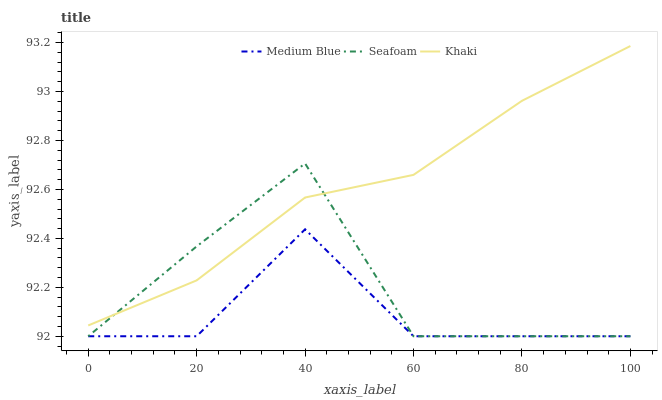Does Medium Blue have the minimum area under the curve?
Answer yes or no. Yes. Does Khaki have the maximum area under the curve?
Answer yes or no. Yes. Does Seafoam have the minimum area under the curve?
Answer yes or no. No. Does Seafoam have the maximum area under the curve?
Answer yes or no. No. Is Khaki the smoothest?
Answer yes or no. Yes. Is Seafoam the roughest?
Answer yes or no. Yes. Is Medium Blue the smoothest?
Answer yes or no. No. Is Medium Blue the roughest?
Answer yes or no. No. Does Khaki have the highest value?
Answer yes or no. Yes. Does Seafoam have the highest value?
Answer yes or no. No. Is Medium Blue less than Khaki?
Answer yes or no. Yes. Is Khaki greater than Medium Blue?
Answer yes or no. Yes. Does Seafoam intersect Medium Blue?
Answer yes or no. Yes. Is Seafoam less than Medium Blue?
Answer yes or no. No. Is Seafoam greater than Medium Blue?
Answer yes or no. No. Does Medium Blue intersect Khaki?
Answer yes or no. No. 